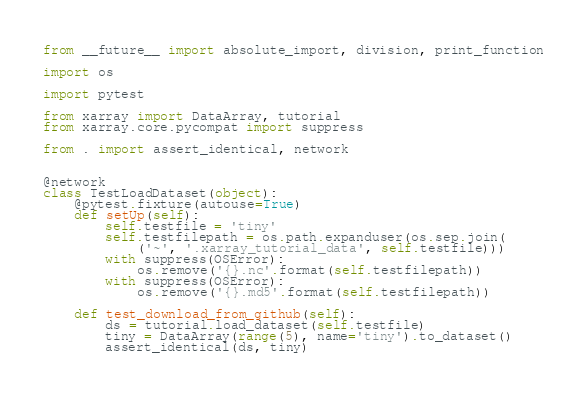<code> <loc_0><loc_0><loc_500><loc_500><_Python_>from __future__ import absolute_import, division, print_function

import os

import pytest

from xarray import DataArray, tutorial
from xarray.core.pycompat import suppress

from . import assert_identical, network


@network
class TestLoadDataset(object):
    @pytest.fixture(autouse=True)
    def setUp(self):
        self.testfile = 'tiny'
        self.testfilepath = os.path.expanduser(os.sep.join(
            ('~', '.xarray_tutorial_data', self.testfile)))
        with suppress(OSError):
            os.remove('{}.nc'.format(self.testfilepath))
        with suppress(OSError):
            os.remove('{}.md5'.format(self.testfilepath))

    def test_download_from_github(self):
        ds = tutorial.load_dataset(self.testfile)
        tiny = DataArray(range(5), name='tiny').to_dataset()
        assert_identical(ds, tiny)
</code> 